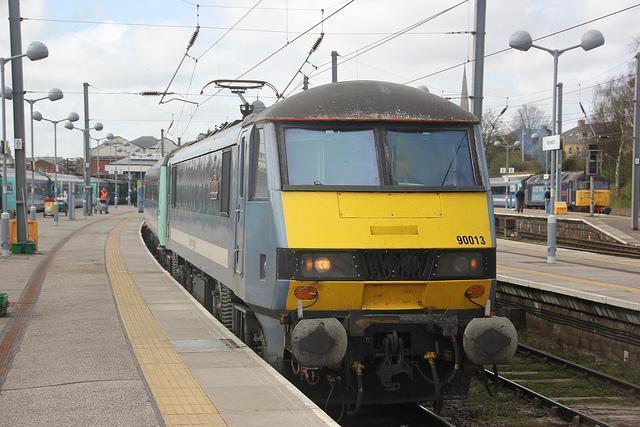How many points of contact between the train and the cables?
Give a very brief answer. 2. How many trains are in the photo?
Give a very brief answer. 3. 